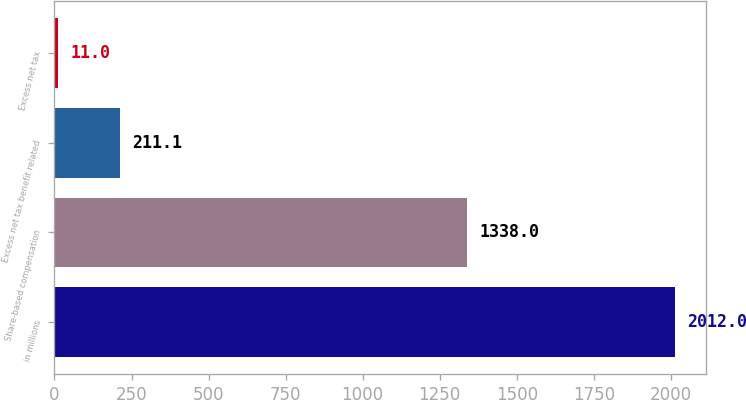Convert chart to OTSL. <chart><loc_0><loc_0><loc_500><loc_500><bar_chart><fcel>in millions<fcel>Share-based compensation<fcel>Excess net tax benefit related<fcel>Excess net tax<nl><fcel>2012<fcel>1338<fcel>211.1<fcel>11<nl></chart> 